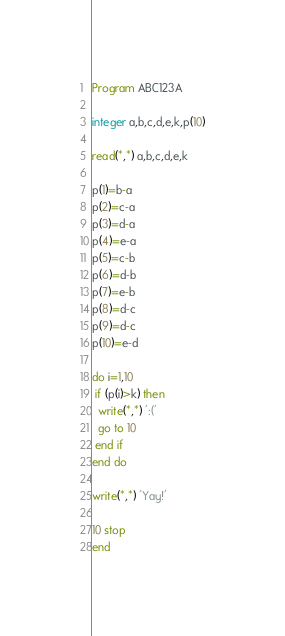<code> <loc_0><loc_0><loc_500><loc_500><_FORTRAN_>Program ABC123A

integer a,b,c,d,e,k,p(10)

read(*,*) a,b,c,d,e,k

p(1)=b-a
p(2)=c-a
p(3)=d-a
p(4)=e-a
p(5)=c-b
p(6)=d-b
p(7)=e-b
p(8)=d-c
p(9)=d-c
p(10)=e-d

do i=1,10
 if (p(i)>k) then
  write(*,*) ':('
  go to 10
 end if
end do

write(*,*) 'Yay!'

10 stop
end</code> 